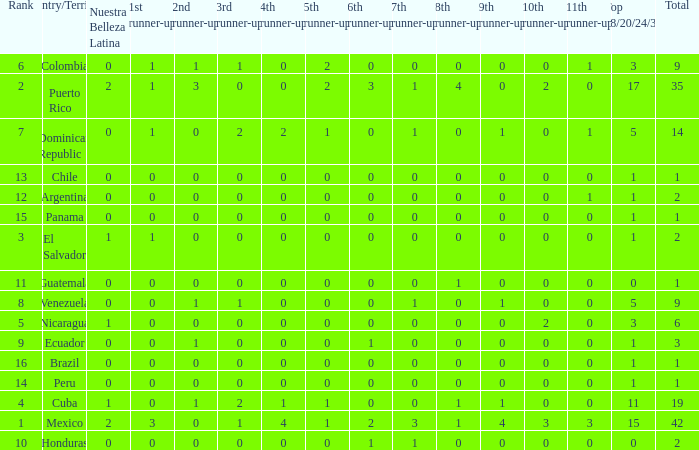What is the total number of 3rd runners-up of the country ranked lower than 12 with a 10th runner-up of 0, an 8th runner-up less than 1, and a 7th runner-up of 0? 4.0. 